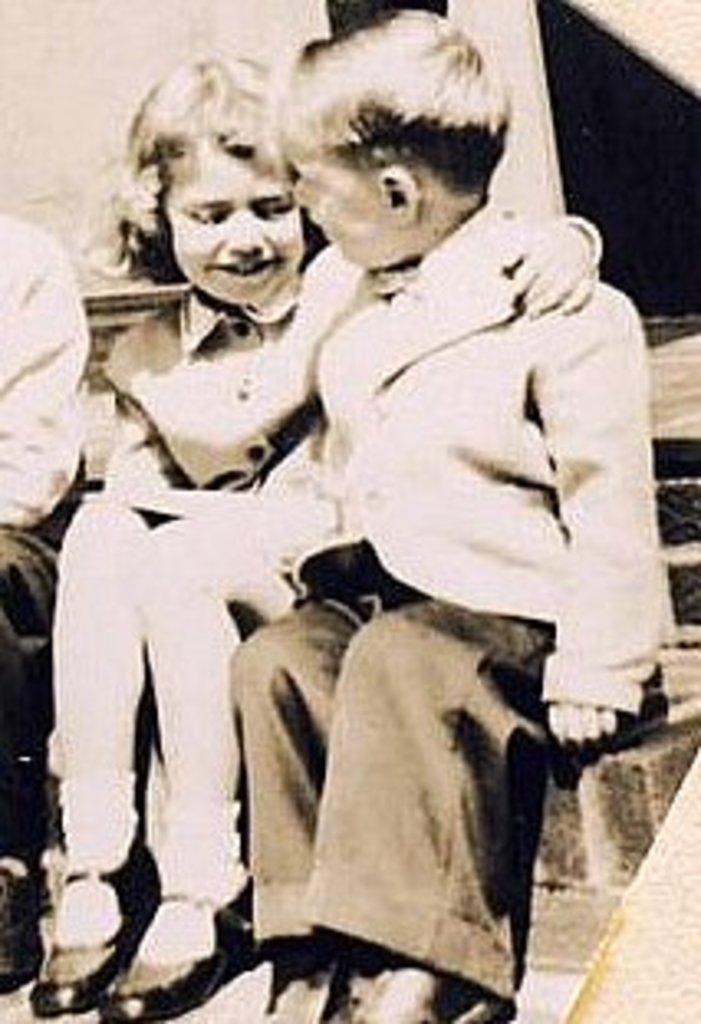Could you give a brief overview of what you see in this image? In front of the image there are three people sitting. Behind them there is a wall. 